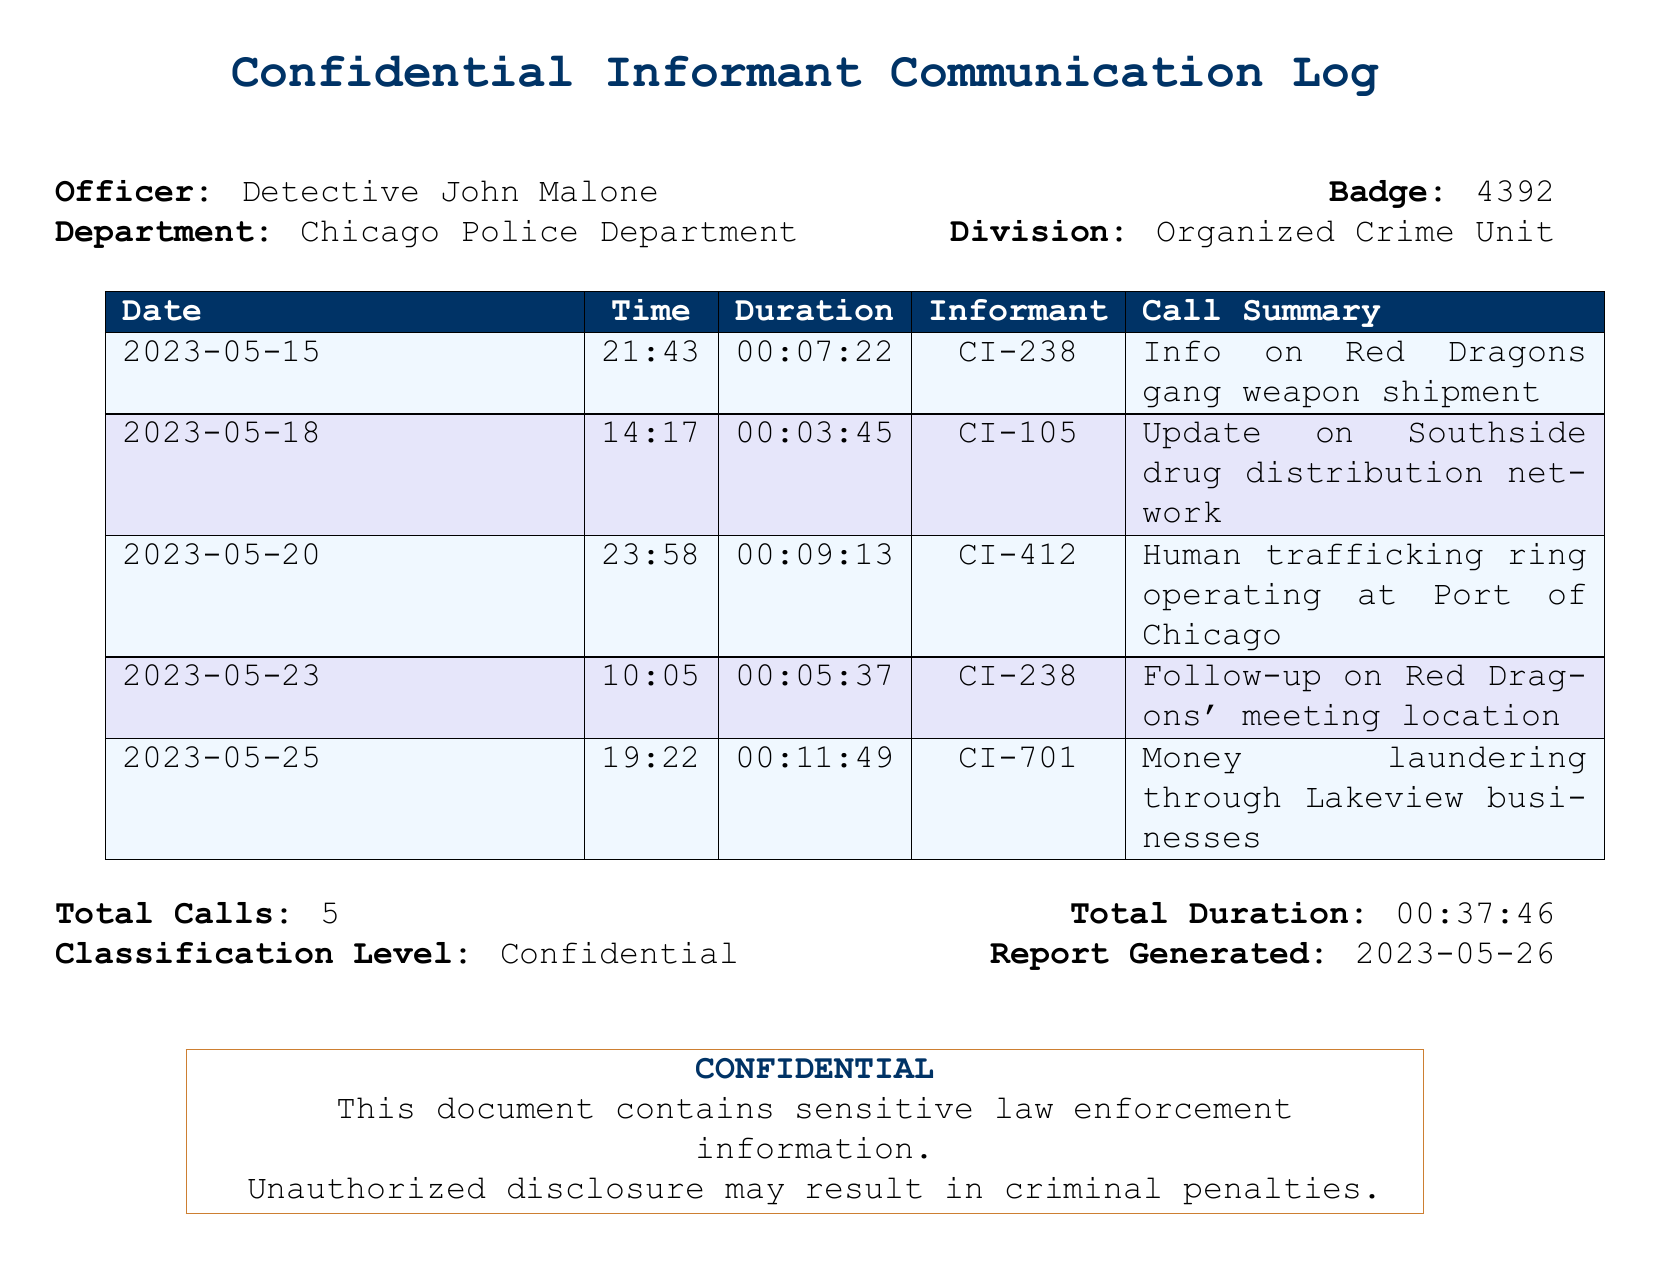What is the date of the first call? The first call is on May 15, 2023, as listed in the table.
Answer: 2023-05-15 Who is the informant for the follow-up call on Red Dragons' meeting location? The informant CI-238 is mentioned in the row for the follow-up call on the Red Dragons' meeting location.
Answer: CI-238 What is the duration of the call regarding the human trafficking ring? The call about the human trafficking ring has a duration of 9 minutes and 13 seconds, as stated in the call summary.
Answer: 00:09:13 How many total calls are recorded? The total calls listed in the document is the sum of all entries in the table.
Answer: 5 What type of criminal activity is CI-701 reporting on? The call summary for CI-701 indicates the report is about money laundering.
Answer: Money laundering 